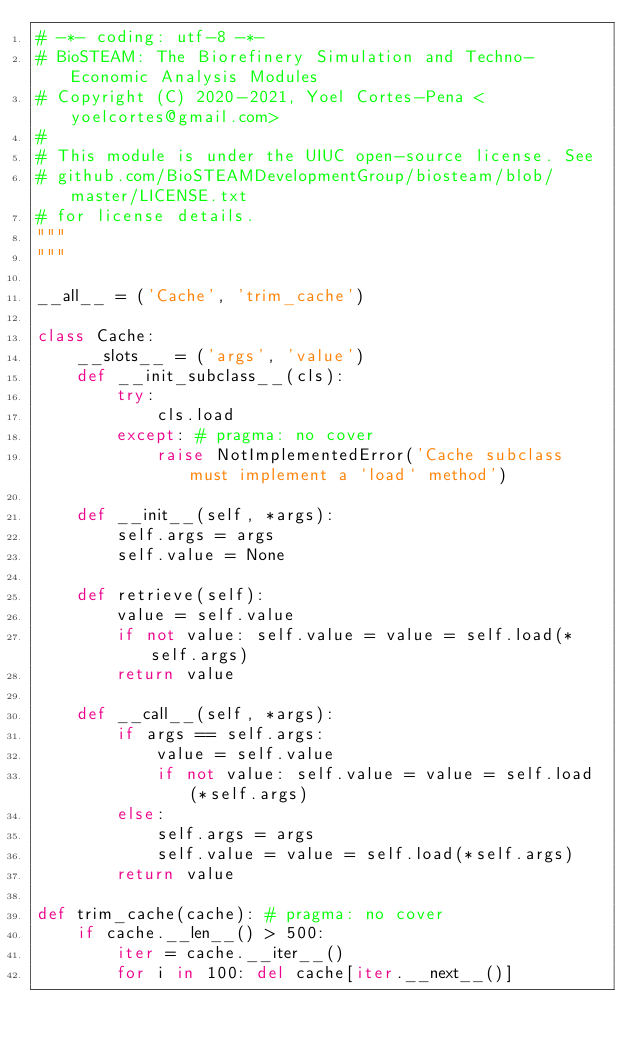<code> <loc_0><loc_0><loc_500><loc_500><_Python_># -*- coding: utf-8 -*-
# BioSTEAM: The Biorefinery Simulation and Techno-Economic Analysis Modules
# Copyright (C) 2020-2021, Yoel Cortes-Pena <yoelcortes@gmail.com>
# 
# This module is under the UIUC open-source license. See 
# github.com/BioSTEAMDevelopmentGroup/biosteam/blob/master/LICENSE.txt
# for license details.
"""
"""

__all__ = ('Cache', 'trim_cache') 

class Cache:
    __slots__ = ('args', 'value')
    def __init_subclass__(cls):
        try:
            cls.load
        except: # pragma: no cover
            raise NotImplementedError('Cache subclass must implement a `load` method')
    
    def __init__(self, *args):
        self.args = args
        self.value = None
    
    def retrieve(self):
        value = self.value
        if not value: self.value = value = self.load(*self.args)
        return value
    
    def __call__(self, *args):
        if args == self.args:
            value = self.value
            if not value: self.value = value = self.load(*self.args)
        else:
            self.args = args
            self.value = value = self.load(*self.args)
        return value
    
def trim_cache(cache): # pragma: no cover
    if cache.__len__() > 500: 
        iter = cache.__iter__()
        for i in 100: del cache[iter.__next__()]</code> 